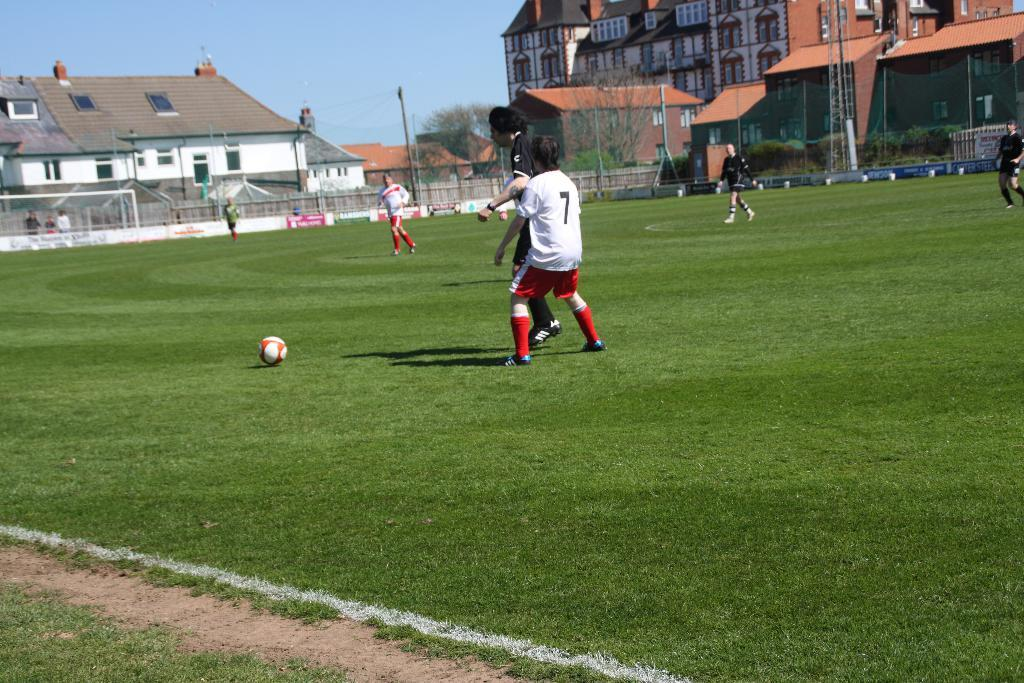What activity are the people in the image engaged in? The people in the image are playing football. What type of surface are they playing on? There is green grass at the bottom of the image. What can be seen in the distance behind the people playing football? There are buildings in the background of the image. What is visible at the top of the image? The sky is visible at the top of the image. Can you see any agreements being signed in the image? There is no reference to any agreements or signing in the image; it features people playing football on green grass with buildings in the background and the sky visible at the top. 